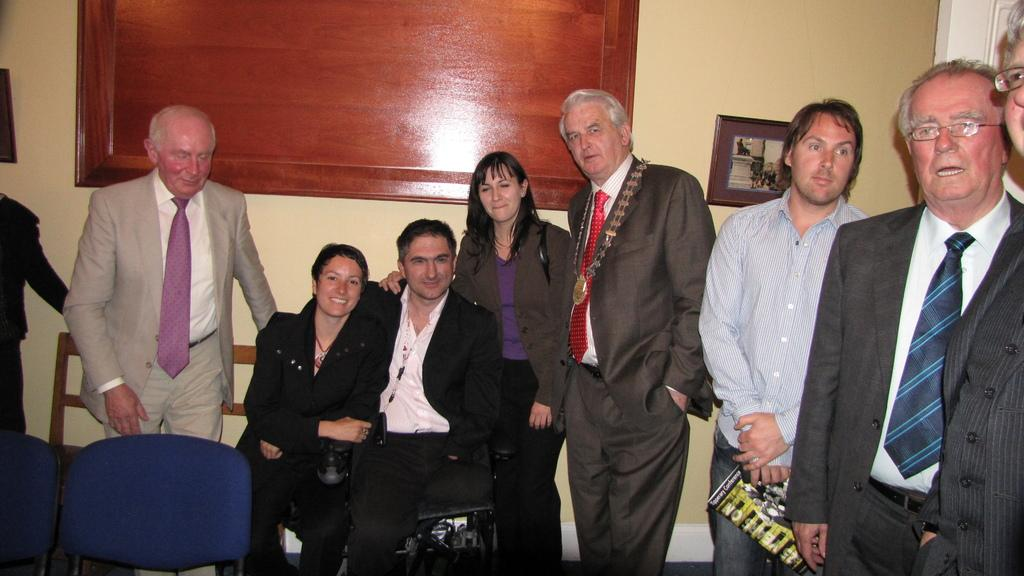How many people are sitting in the image? There are two persons sitting on chairs in the image. What is the background of the image? There is a wall in the image. What is present on the wall? There is a frame in the image. What is the primary surface on which people are standing in the image? There are people standing on the floor in the image. What type of plants can be seen growing on the chairs in the image? There are no plants visible on the chairs in the image. 